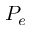Convert formula to latex. <formula><loc_0><loc_0><loc_500><loc_500>P _ { e }</formula> 